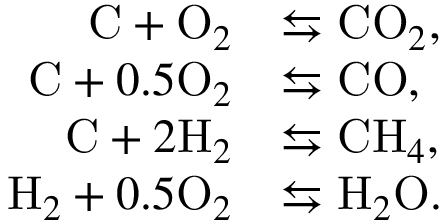<formula> <loc_0><loc_0><loc_500><loc_500>\begin{array} { r l } { C + O _ { 2 } } & { \leftrightarrow s C O _ { 2 } , } \\ { C + 0 . 5 O _ { 2 } } & { \leftrightarrow s C O , } \\ { C + 2 H _ { 2 } } & { \leftrightarrow s C H _ { 4 } , } \\ { H _ { 2 } + 0 . 5 O _ { 2 } } & { \leftrightarrow s H _ { 2 } O . } \end{array}</formula> 